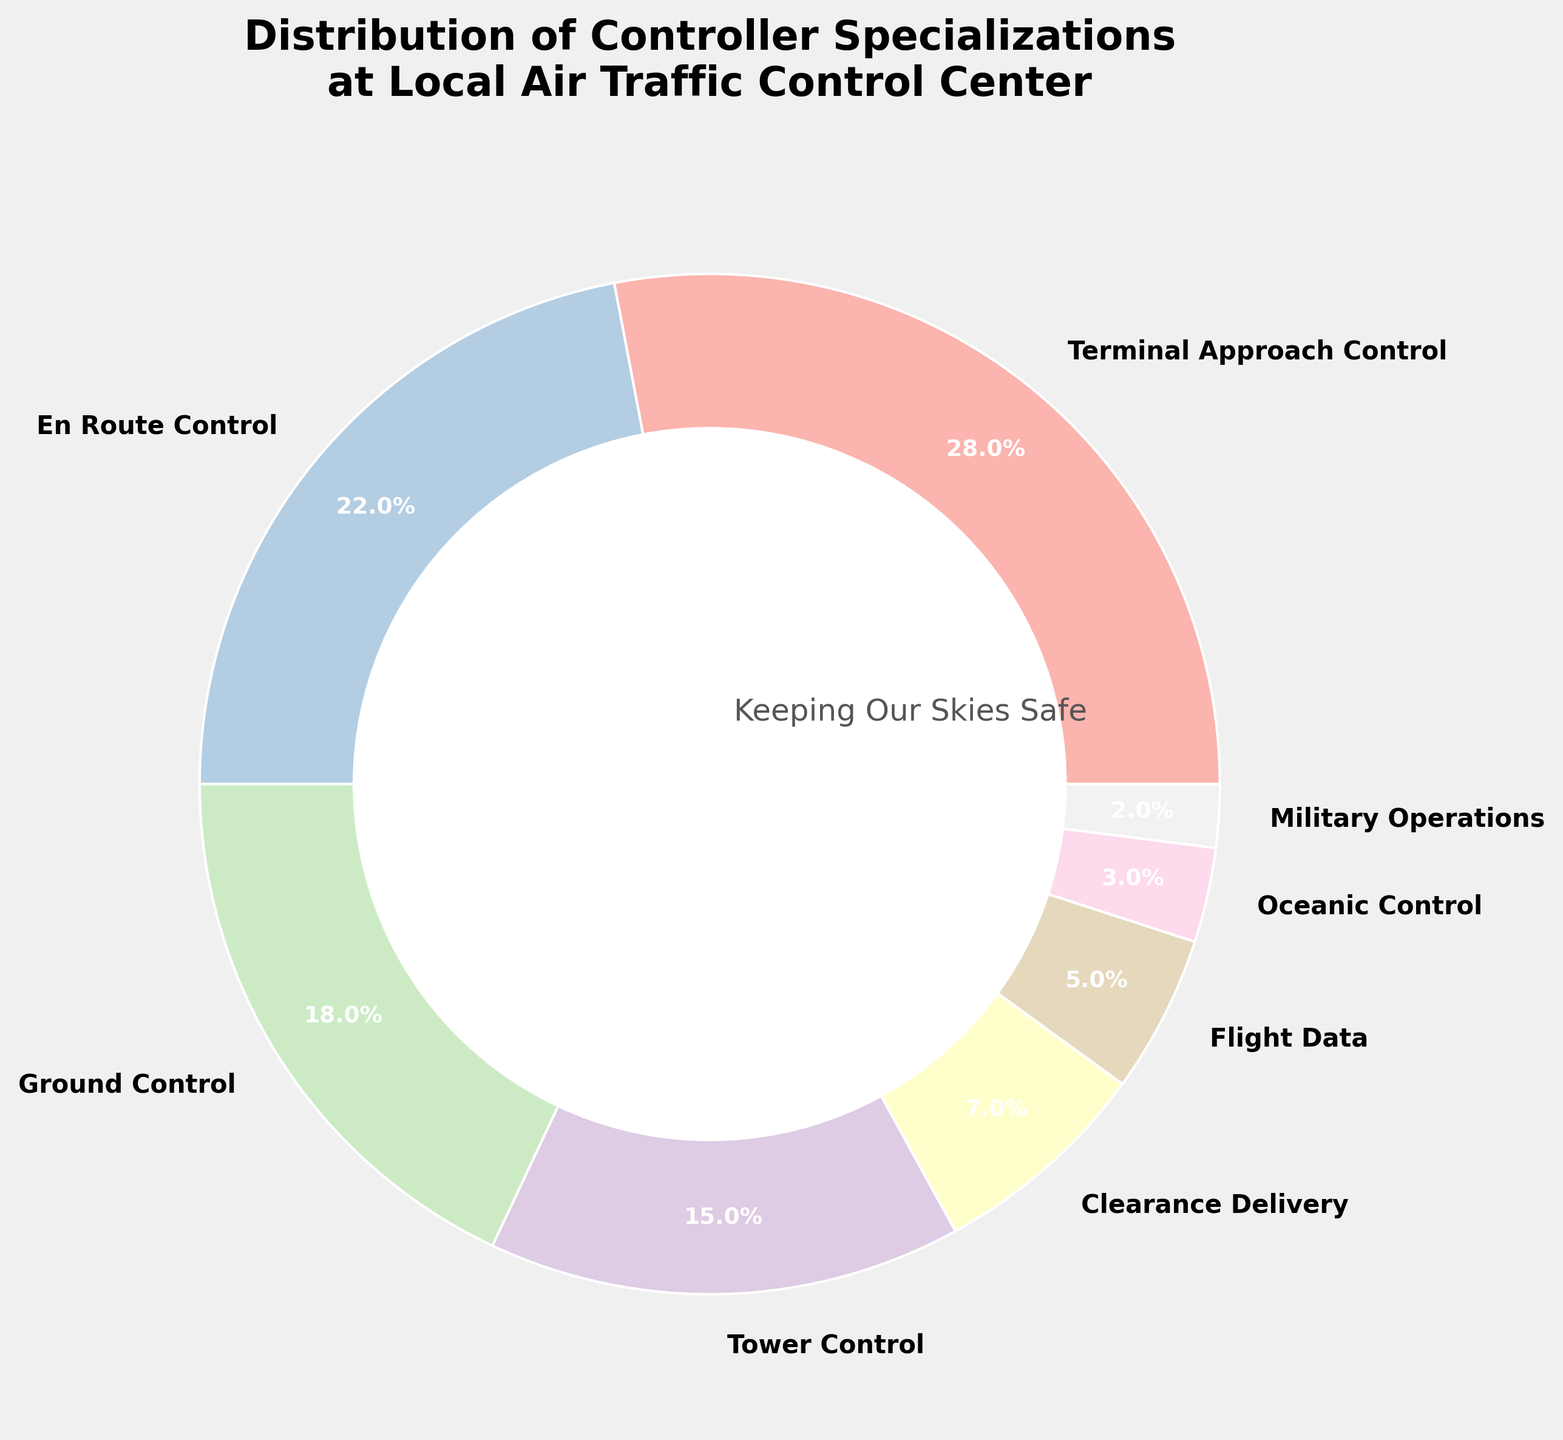Which specialization has the highest percentage? The slice labeled "Terminal Approach Control" has the highest percentage.
Answer: Terminal Approach Control Which specialization has the smallest representation? The slice labeled "Military Operations" has the smallest representation.
Answer: Military Operations How many specializations have a percentage greater than 20%? By looking at the pie chart, "Terminal Approach Control" and "En Route Control" each have percentages greater than 20%.
Answer: 2 What is the total percentage of specializations that make up more than 15% of the distribution? Terminal Approach Control (28%), En Route Control (22%), and Ground Control (18%): 28 + 22 + 18 = 68%.
Answer: 68% Which specializations combined make up less than 10%? The slices labeled "Flight Data" (5%), "Oceanic Control" (3%), and "Military Operations" (2%) combined make up less than 10%.
Answer: Flight Data, Oceanic Control, Military Operations How does the percentage of Tower Control compare to that of Ground Control? The percentage for Tower Control (15%) is less than that for Ground Control (18%).
Answer: Less than What is the average percentage of "Terminal Approach Control", "En Route Control", and "Ground Control"? (28 + 22 + 18) / 3 = 68 / 3 = 22.67%.
Answer: 22.67% If you combine "Ground Control" and "Tower Control", what will their combined percentage be? Ground Control (18%) + Tower Control (15%) = 18 + 15 = 33%.
Answer: 33% What is the difference in percentage between "Clearance Delivery" and "Flight Data"? Clearance Delivery (7%) - Flight Data (5%) = 2%.
Answer: 2% 